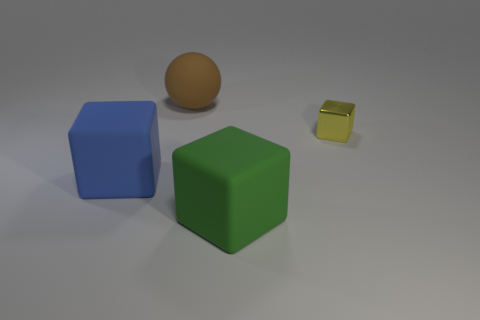Add 4 large gray spheres. How many objects exist? 8 Subtract all blocks. How many objects are left? 1 Add 3 big matte things. How many big matte things are left? 6 Add 2 matte balls. How many matte balls exist? 3 Subtract 1 brown balls. How many objects are left? 3 Subtract all small blue metallic cylinders. Subtract all small yellow cubes. How many objects are left? 3 